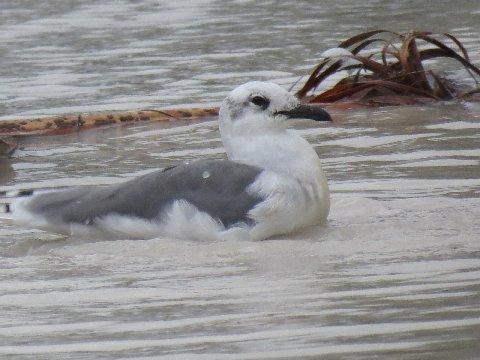Is the bird healthy?
Quick response, please. Yes. What is floating near the bird?
Concise answer only. Branch. Does this bird eat fish?
Concise answer only. Yes. 